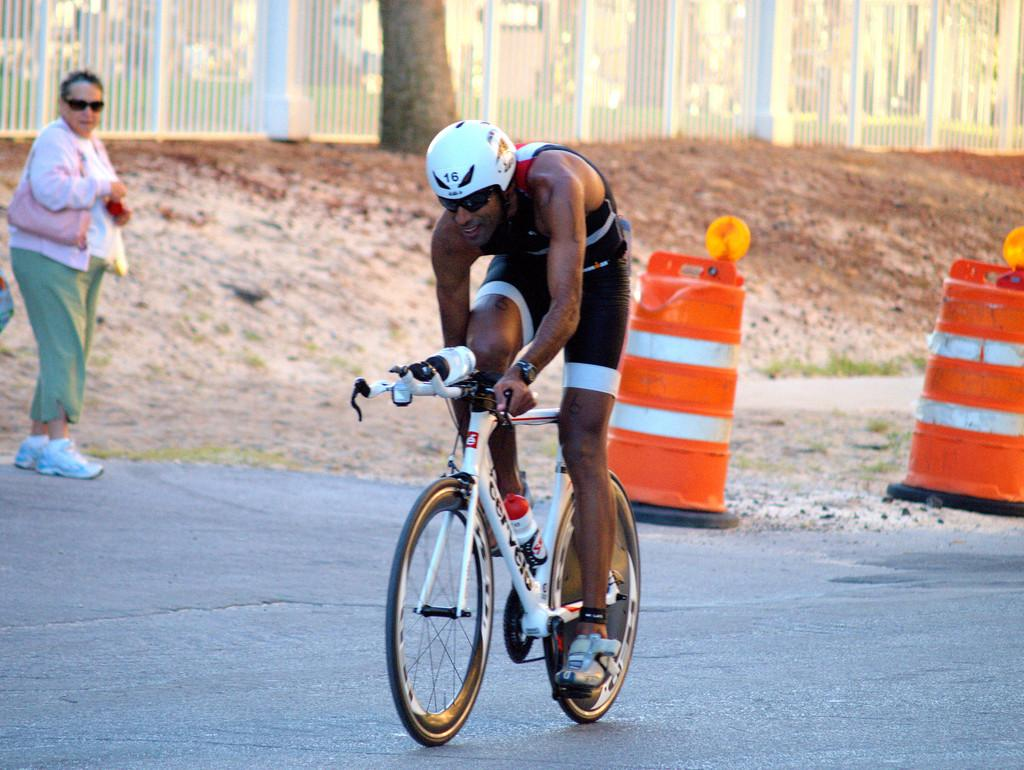What is the man in the image doing? The man is riding a bicycle in the image. What safety precaution is the man taking while riding the bicycle? The man is wearing a helmet. Can you describe the background of the image? There is a woman standing, a fence, a tree, and a traffic pole in the background of the image. What type of current can be seen flowing through the man's toes in the image? There is no indication of the man's toes or any current in the image. 